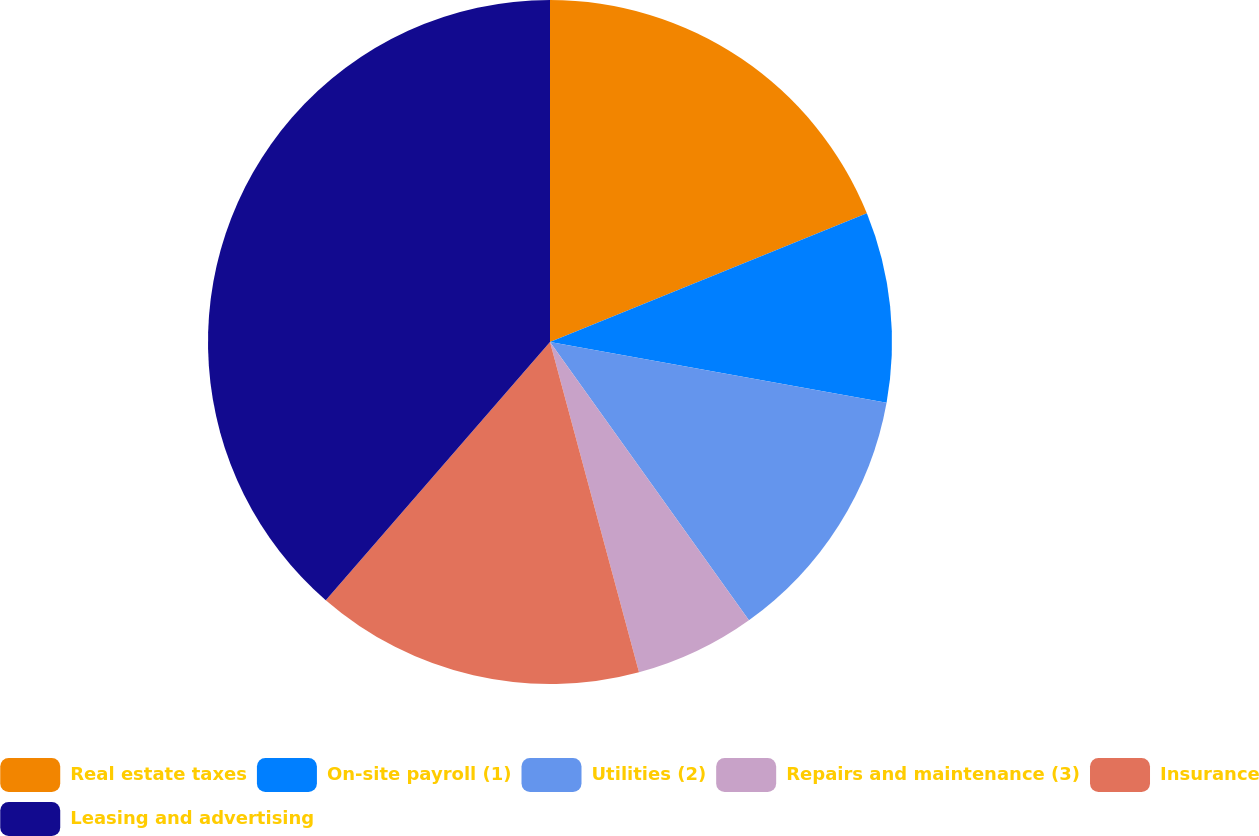<chart> <loc_0><loc_0><loc_500><loc_500><pie_chart><fcel>Real estate taxes<fcel>On-site payroll (1)<fcel>Utilities (2)<fcel>Repairs and maintenance (3)<fcel>Insurance<fcel>Leasing and advertising<nl><fcel>18.86%<fcel>8.98%<fcel>12.28%<fcel>5.69%<fcel>15.57%<fcel>38.62%<nl></chart> 